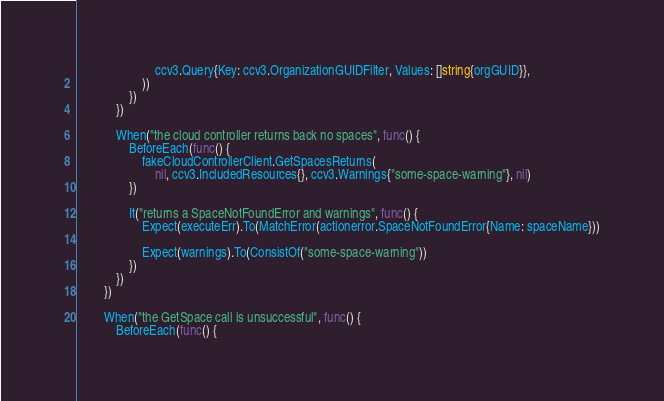Convert code to text. <code><loc_0><loc_0><loc_500><loc_500><_Go_>						ccv3.Query{Key: ccv3.OrganizationGUIDFilter, Values: []string{orgGUID}},
					))
				})
			})

			When("the cloud controller returns back no spaces", func() {
				BeforeEach(func() {
					fakeCloudControllerClient.GetSpacesReturns(
						nil, ccv3.IncludedResources{}, ccv3.Warnings{"some-space-warning"}, nil)
				})

				It("returns a SpaceNotFoundError and warnings", func() {
					Expect(executeErr).To(MatchError(actionerror.SpaceNotFoundError{Name: spaceName}))

					Expect(warnings).To(ConsistOf("some-space-warning"))
				})
			})
		})

		When("the GetSpace call is unsuccessful", func() {
			BeforeEach(func() {</code> 